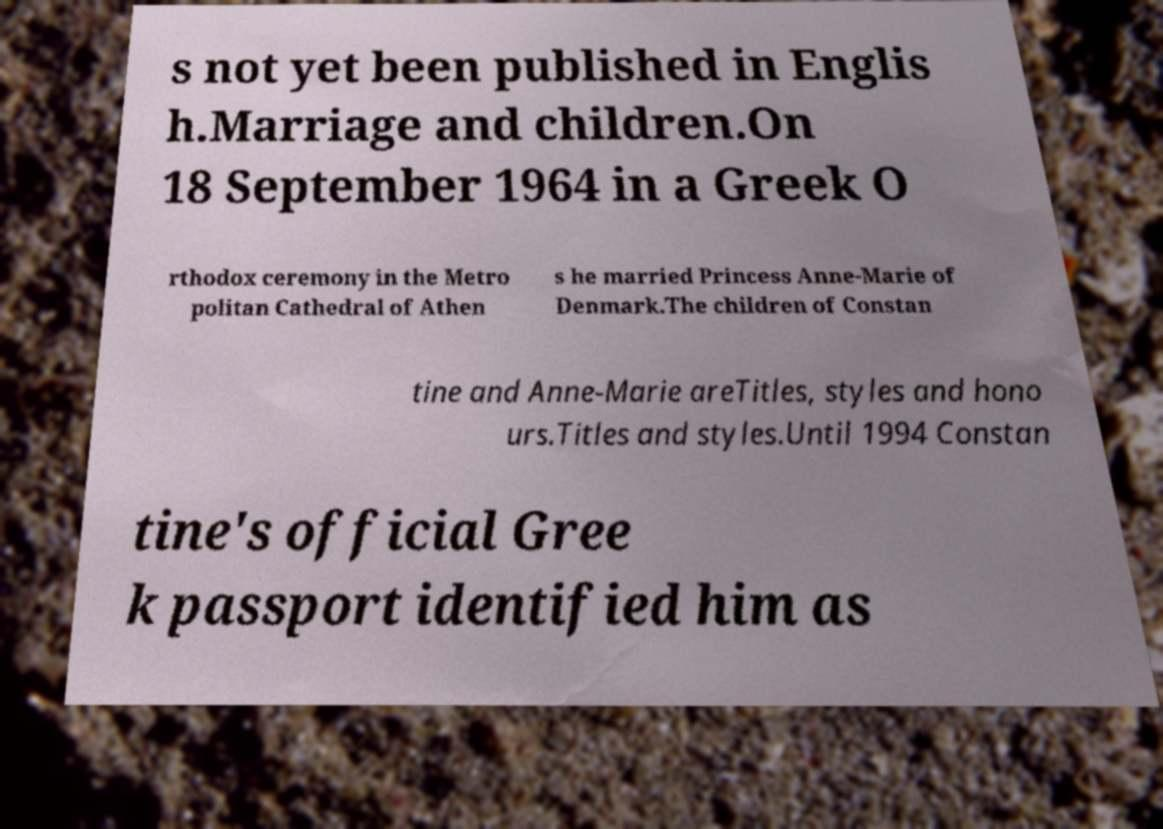Could you assist in decoding the text presented in this image and type it out clearly? s not yet been published in Englis h.Marriage and children.On 18 September 1964 in a Greek O rthodox ceremony in the Metro politan Cathedral of Athen s he married Princess Anne-Marie of Denmark.The children of Constan tine and Anne-Marie areTitles, styles and hono urs.Titles and styles.Until 1994 Constan tine's official Gree k passport identified him as 